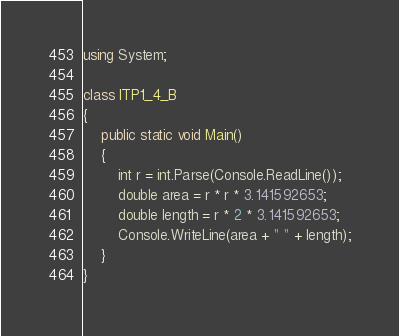<code> <loc_0><loc_0><loc_500><loc_500><_C#_>using System;

class ITP1_4_B
{
    public static void Main()
    {
        int r = int.Parse(Console.ReadLine());
        double area = r * r * 3.141592653;
        double length = r * 2 * 3.141592653;
        Console.WriteLine(area + " " + length);
    }
}</code> 